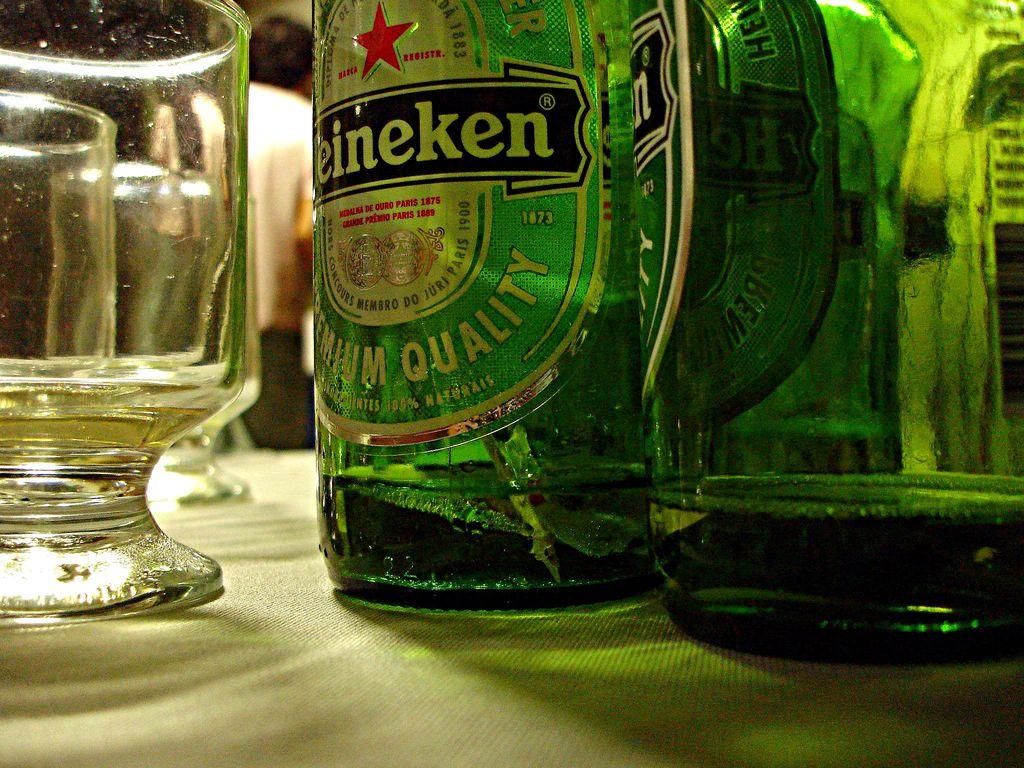What kind of beer is this?
Your response must be concise. Heineken. In which year was the heineken brand established?
Make the answer very short. 1873. 